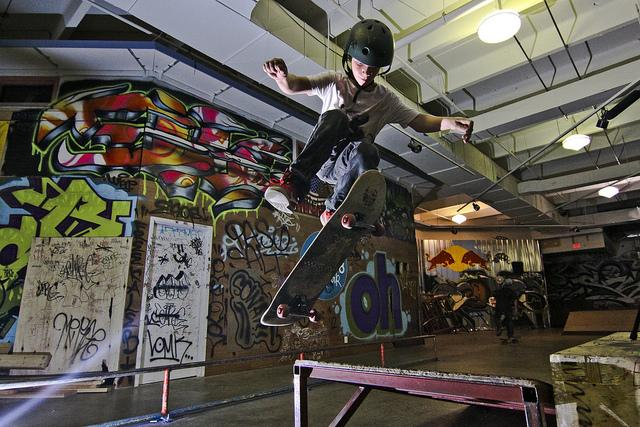How did the skateboarder get so high in the air? jumped 